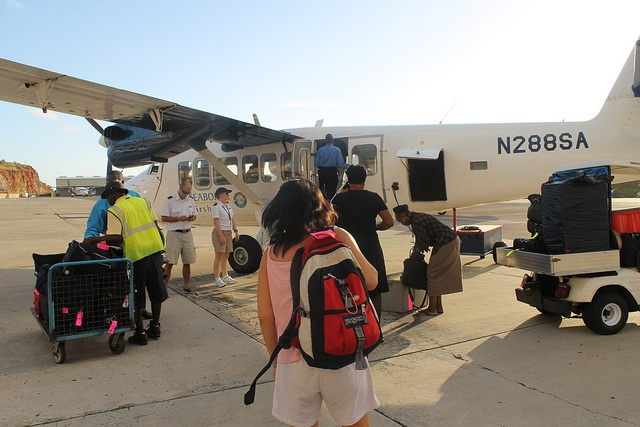Describe the objects in this image and their specific colors. I can see airplane in lightblue, darkgray, black, and gray tones, truck in lightblue, black, tan, gray, and darkgray tones, people in lightblue, gray, black, and brown tones, backpack in lightblue, black, brown, maroon, and gray tones, and people in lightblue, black, olive, tan, and khaki tones in this image. 